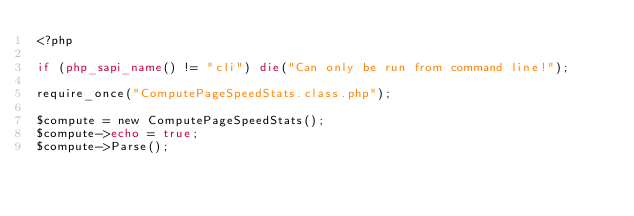Convert code to text. <code><loc_0><loc_0><loc_500><loc_500><_PHP_><?php

if (php_sapi_name() != "cli") die("Can only be run from command line!");

require_once("ComputePageSpeedStats.class.php");

$compute = new ComputePageSpeedStats();
$compute->echo = true;
$compute->Parse();



</code> 